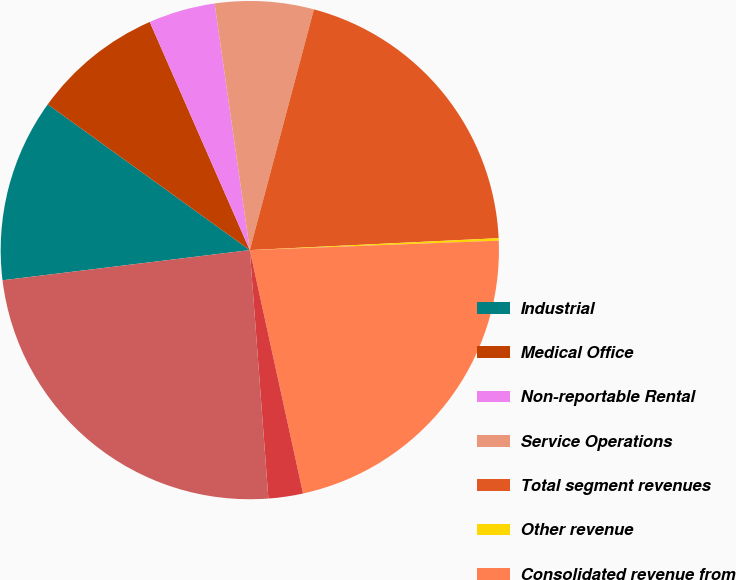<chart> <loc_0><loc_0><loc_500><loc_500><pie_chart><fcel>Industrial<fcel>Medical Office<fcel>Non-reportable Rental<fcel>Service Operations<fcel>Total segment revenues<fcel>Other revenue<fcel>Consolidated revenue from<fcel>Discontinued operations<fcel>Consolidated revenue<nl><fcel>11.88%<fcel>8.48%<fcel>4.32%<fcel>6.4%<fcel>20.1%<fcel>0.16%<fcel>22.18%<fcel>2.24%<fcel>24.26%<nl></chart> 